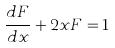<formula> <loc_0><loc_0><loc_500><loc_500>\frac { d F } { d x } + 2 x F = 1</formula> 